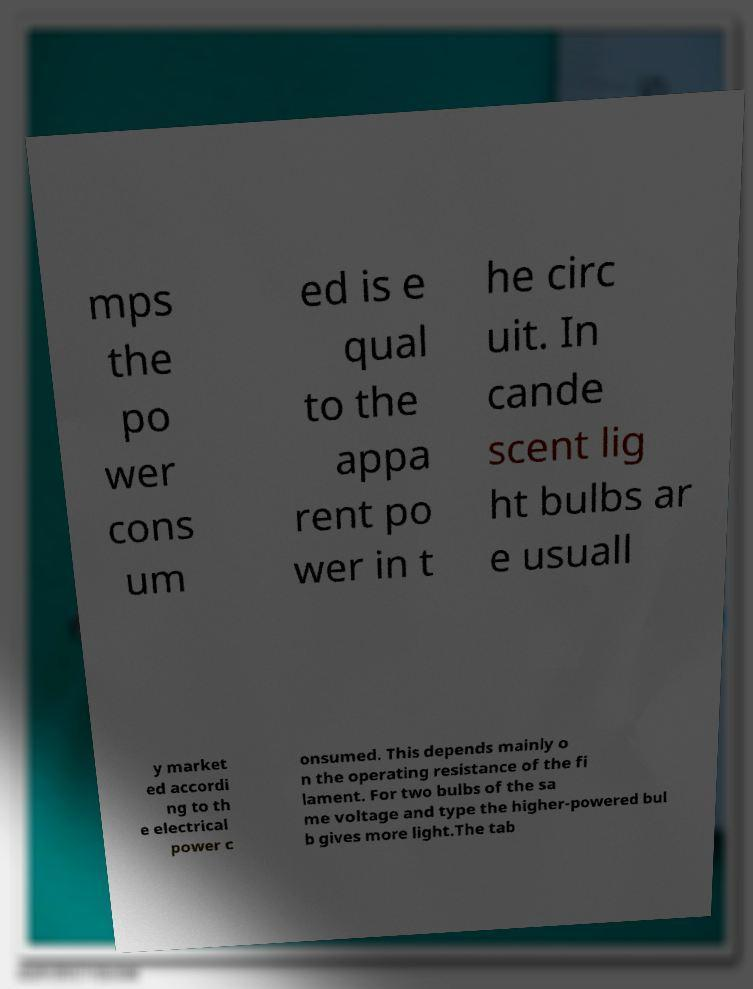Could you assist in decoding the text presented in this image and type it out clearly? mps the po wer cons um ed is e qual to the appa rent po wer in t he circ uit. In cande scent lig ht bulbs ar e usuall y market ed accordi ng to th e electrical power c onsumed. This depends mainly o n the operating resistance of the fi lament. For two bulbs of the sa me voltage and type the higher-powered bul b gives more light.The tab 